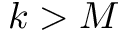<formula> <loc_0><loc_0><loc_500><loc_500>k > M</formula> 